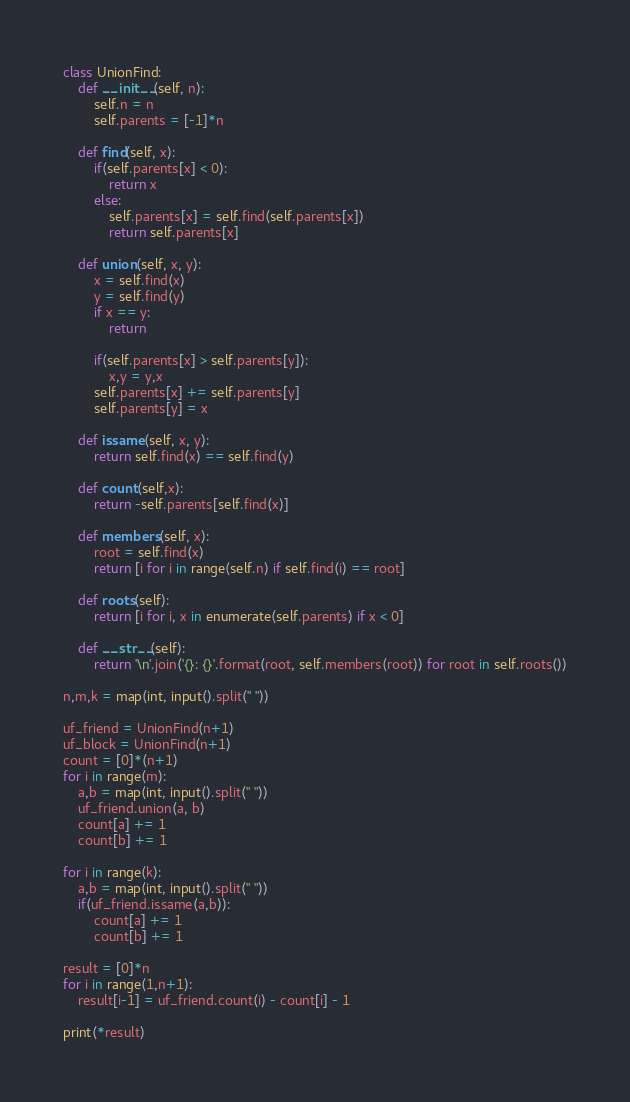Convert code to text. <code><loc_0><loc_0><loc_500><loc_500><_Python_>
class UnionFind:
    def __init__(self, n):
        self.n = n
        self.parents = [-1]*n

    def find(self, x):
        if(self.parents[x] < 0):
            return x
        else:
            self.parents[x] = self.find(self.parents[x])
            return self.parents[x]

    def union(self, x, y):
        x = self.find(x)
        y = self.find(y)
        if x == y:
            return

        if(self.parents[x] > self.parents[y]):
            x,y = y,x        
        self.parents[x] += self.parents[y]
        self.parents[y] = x

    def issame(self, x, y):
        return self.find(x) == self.find(y)

    def count(self,x):
        return -self.parents[self.find(x)]

    def members(self, x):
        root = self.find(x)
        return [i for i in range(self.n) if self.find(i) == root]

    def roots(self):
        return [i for i, x in enumerate(self.parents) if x < 0]

    def __str__(self):
        return '\n'.join('{}: {}'.format(root, self.members(root)) for root in self.roots())

n,m,k = map(int, input().split(" "))

uf_friend = UnionFind(n+1)
uf_block = UnionFind(n+1)
count = [0]*(n+1)
for i in range(m):
    a,b = map(int, input().split(" "))
    uf_friend.union(a, b)
    count[a] += 1
    count[b] += 1

for i in range(k):
    a,b = map(int, input().split(" "))
    if(uf_friend.issame(a,b)):
        count[a] += 1
        count[b] += 1

result = [0]*n
for i in range(1,n+1):
    result[i-1] = uf_friend.count(i) - count[i] - 1

print(*result)</code> 